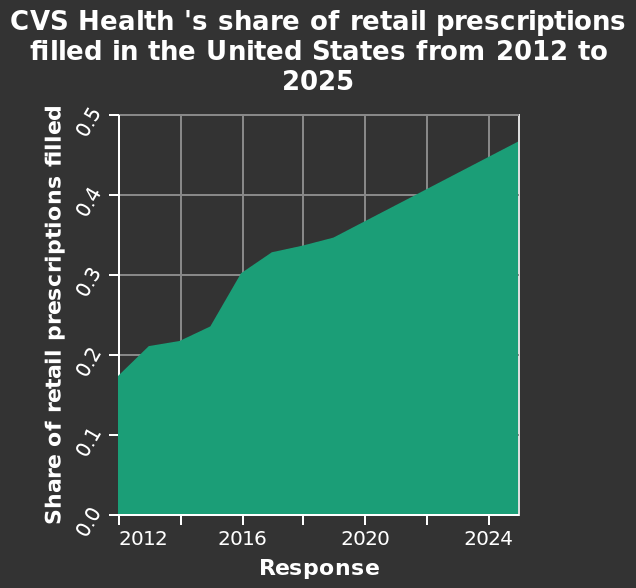<image>
What is the title of the area diagram?  The title of the area diagram is "CVS Health's share of retail prescriptions filled in the United States from 2012 to 2025." 